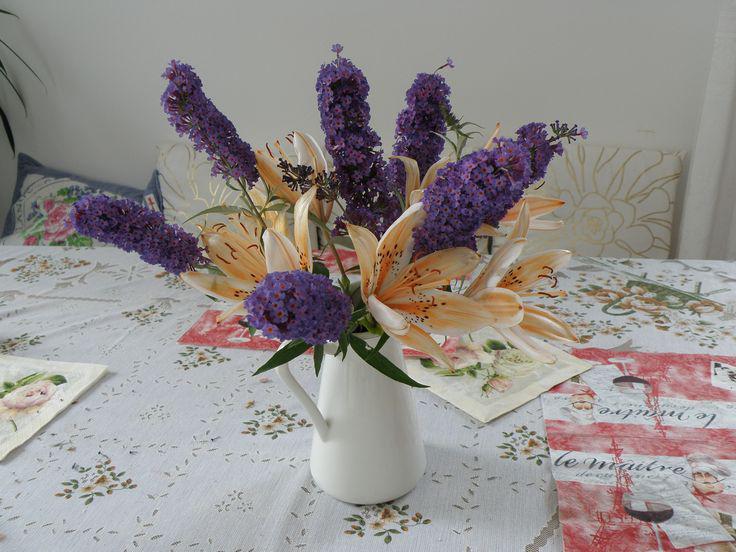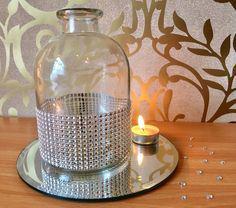The first image is the image on the left, the second image is the image on the right. Examine the images to the left and right. Is the description "There are flowers in a vase in the image on the left." accurate? Answer yes or no. Yes. 